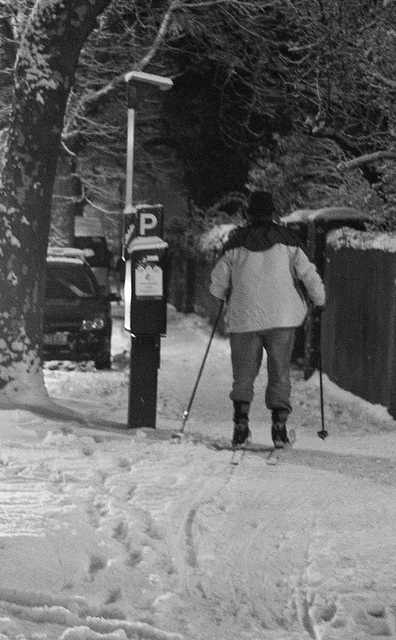<image>What number is on the post in the background? I can't tell what number is on the post in the background as it seems there is no visible number. What number is on the post in the background? There is no number on the post in the background. 